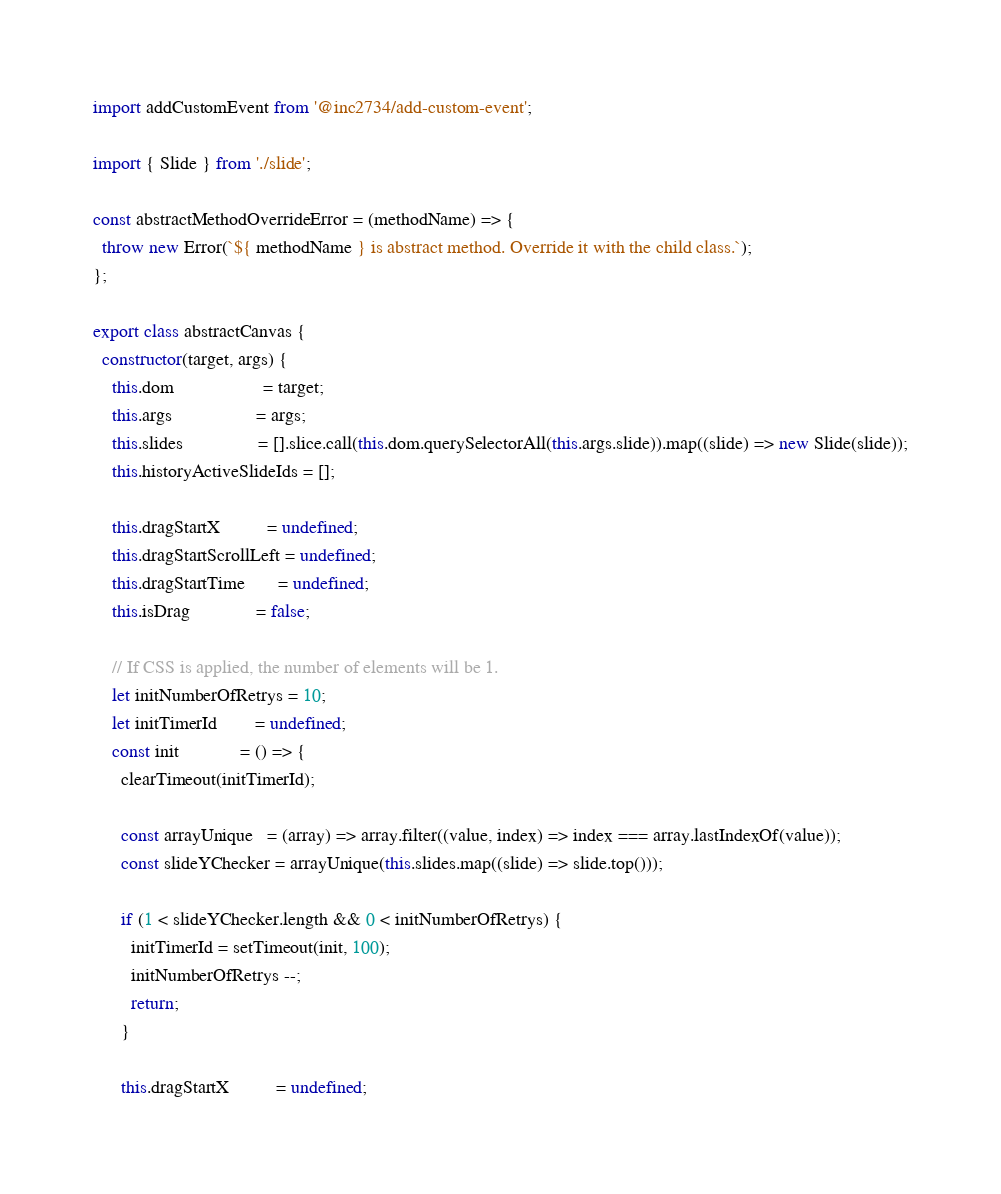<code> <loc_0><loc_0><loc_500><loc_500><_JavaScript_>import addCustomEvent from '@inc2734/add-custom-event';

import { Slide } from './slide';

const abstractMethodOverrideError = (methodName) => {
  throw new Error(`${ methodName } is abstract method. Override it with the child class.`);
};

export class abstractCanvas {
  constructor(target, args) {
    this.dom                   = target;
    this.args                  = args;
    this.slides                = [].slice.call(this.dom.querySelectorAll(this.args.slide)).map((slide) => new Slide(slide));
    this.historyActiveSlideIds = [];

    this.dragStartX          = undefined;
    this.dragStartScrollLeft = undefined;
    this.dragStartTime       = undefined;
    this.isDrag              = false;

    // If CSS is applied, the number of elements will be 1.
    let initNumberOfRetrys = 10;
    let initTimerId        = undefined;
    const init             = () => {
      clearTimeout(initTimerId);

      const arrayUnique   = (array) => array.filter((value, index) => index === array.lastIndexOf(value));
      const slideYChecker = arrayUnique(this.slides.map((slide) => slide.top()));

      if (1 < slideYChecker.length && 0 < initNumberOfRetrys) {
        initTimerId = setTimeout(init, 100);
        initNumberOfRetrys --;
        return;
      }

      this.dragStartX          = undefined;</code> 